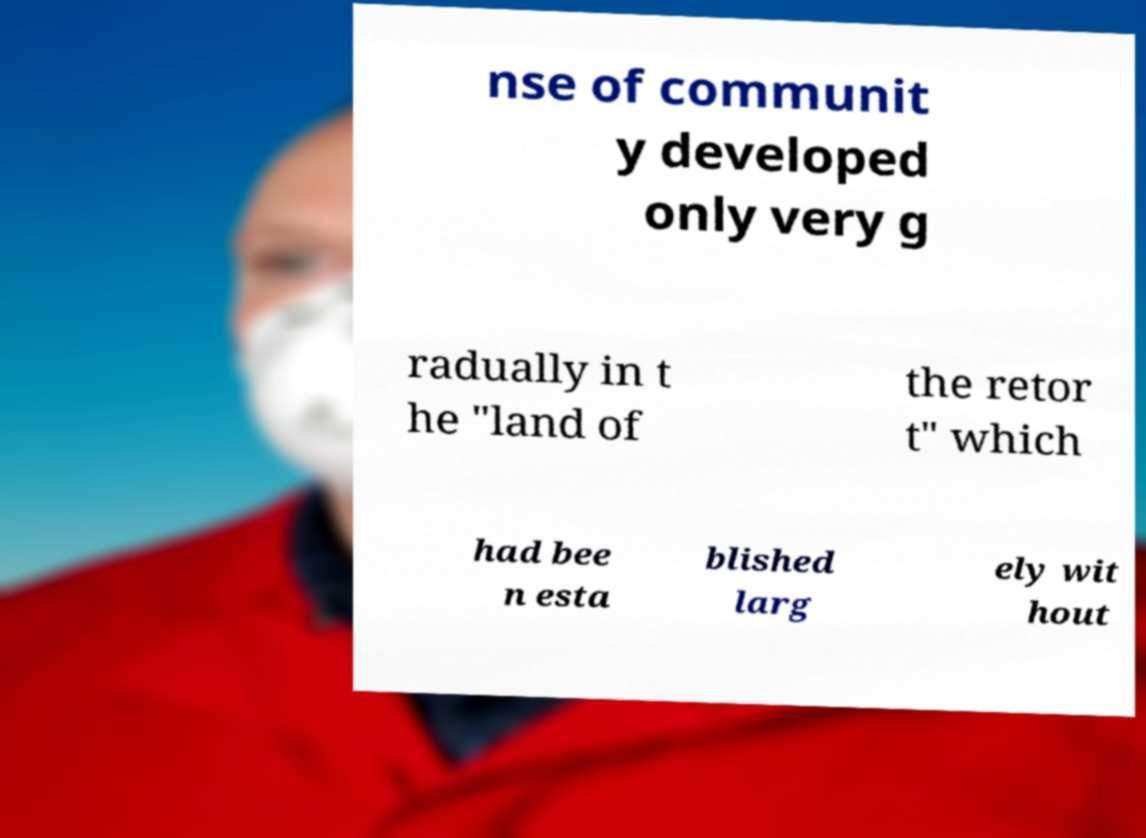Could you extract and type out the text from this image? nse of communit y developed only very g radually in t he "land of the retor t" which had bee n esta blished larg ely wit hout 